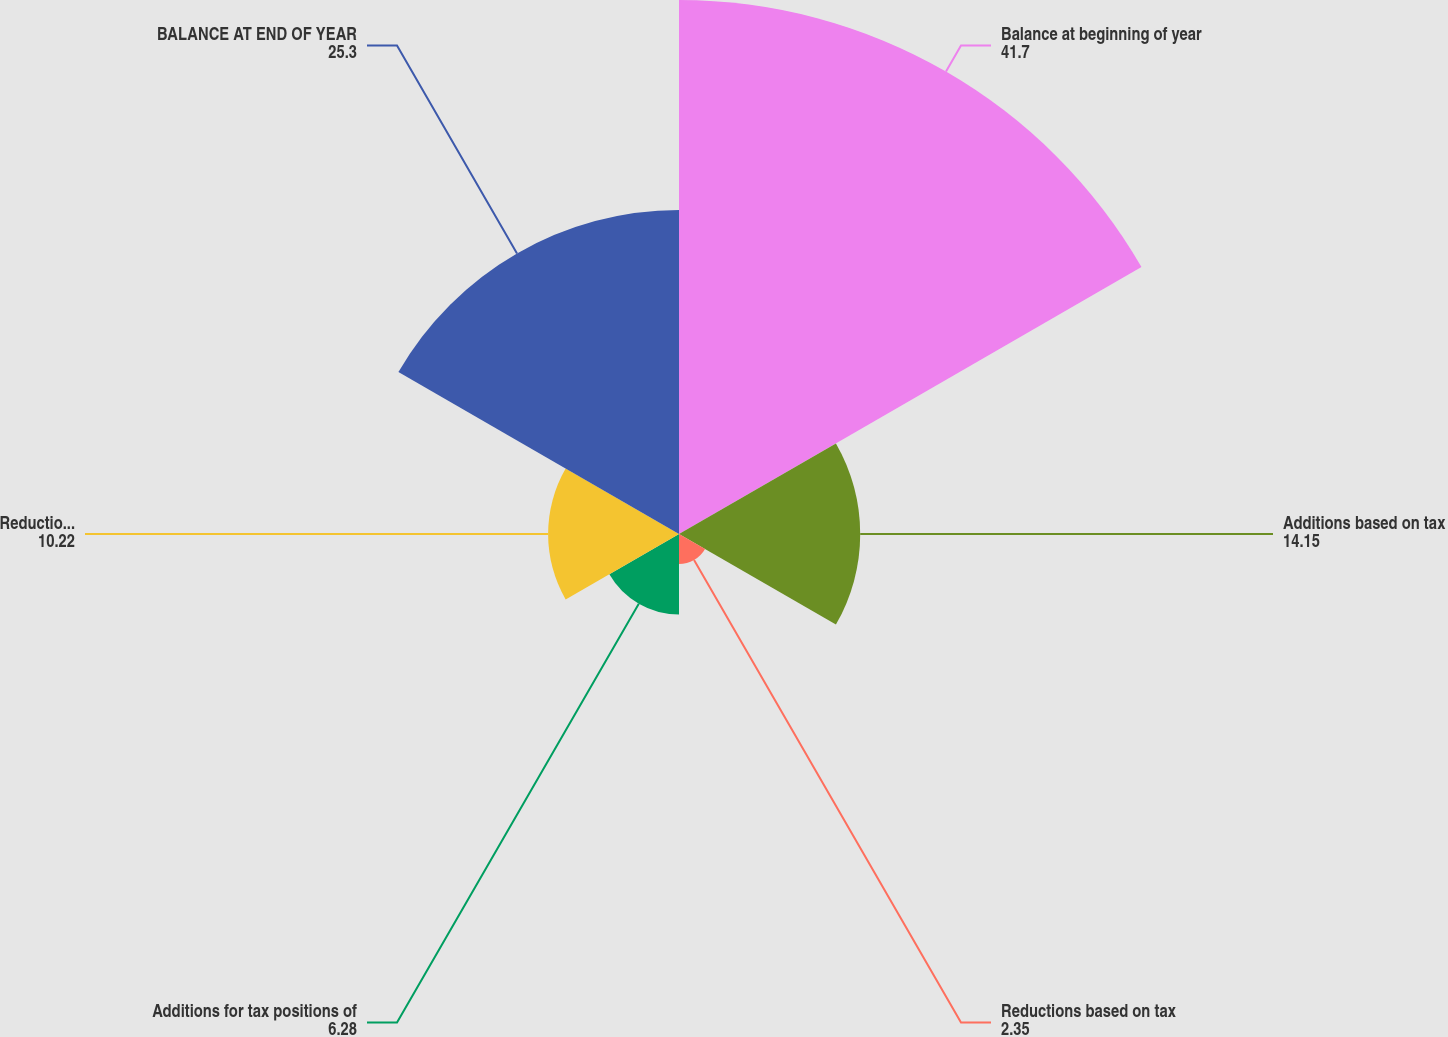Convert chart. <chart><loc_0><loc_0><loc_500><loc_500><pie_chart><fcel>Balance at beginning of year<fcel>Additions based on tax<fcel>Reductions based on tax<fcel>Additions for tax positions of<fcel>Reductions for tax positions<fcel>BALANCE AT END OF YEAR<nl><fcel>41.7%<fcel>14.15%<fcel>2.35%<fcel>6.28%<fcel>10.22%<fcel>25.3%<nl></chart> 